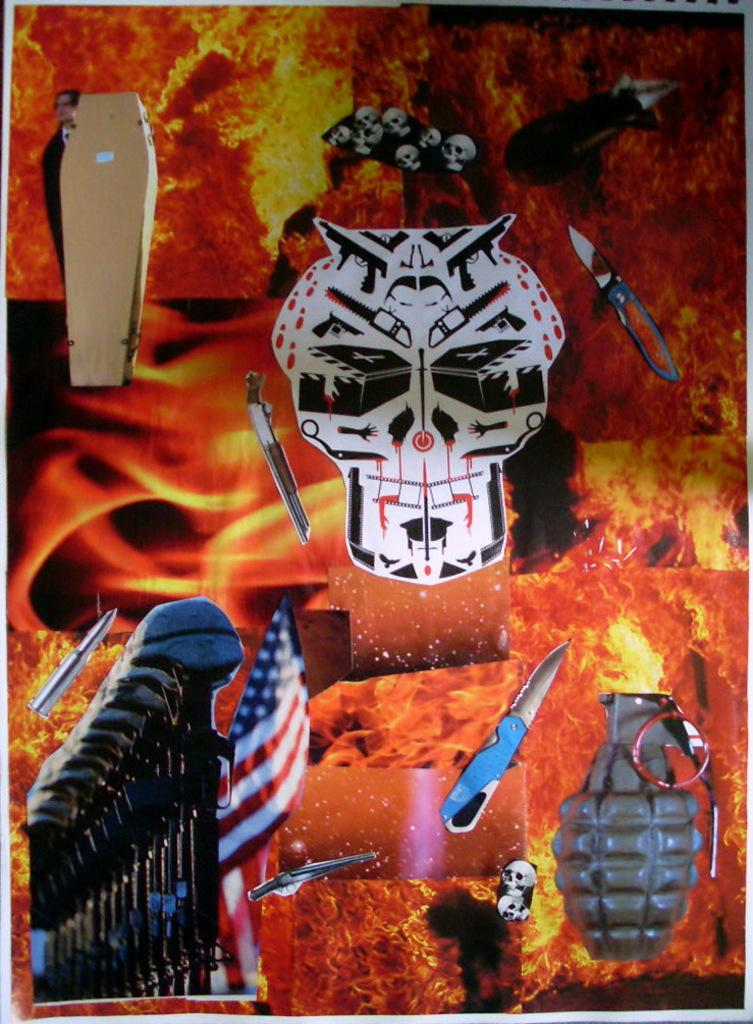What is featured on the poster in the image? The poster contains images of knives, a flag, and a person. Can you describe the images on the poster in more detail? The poster contains images of knives, an image of a flag, and an image of a person. What type of sponge is being used to clean the flag in the image? There is no sponge present in the image, and the flag is not being cleaned. 